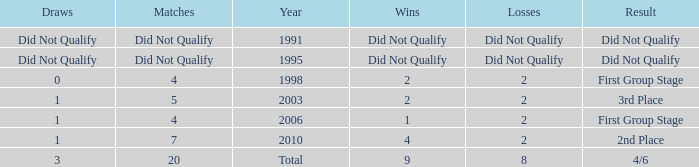What was the result for the team with 3 draws? 4/6. 